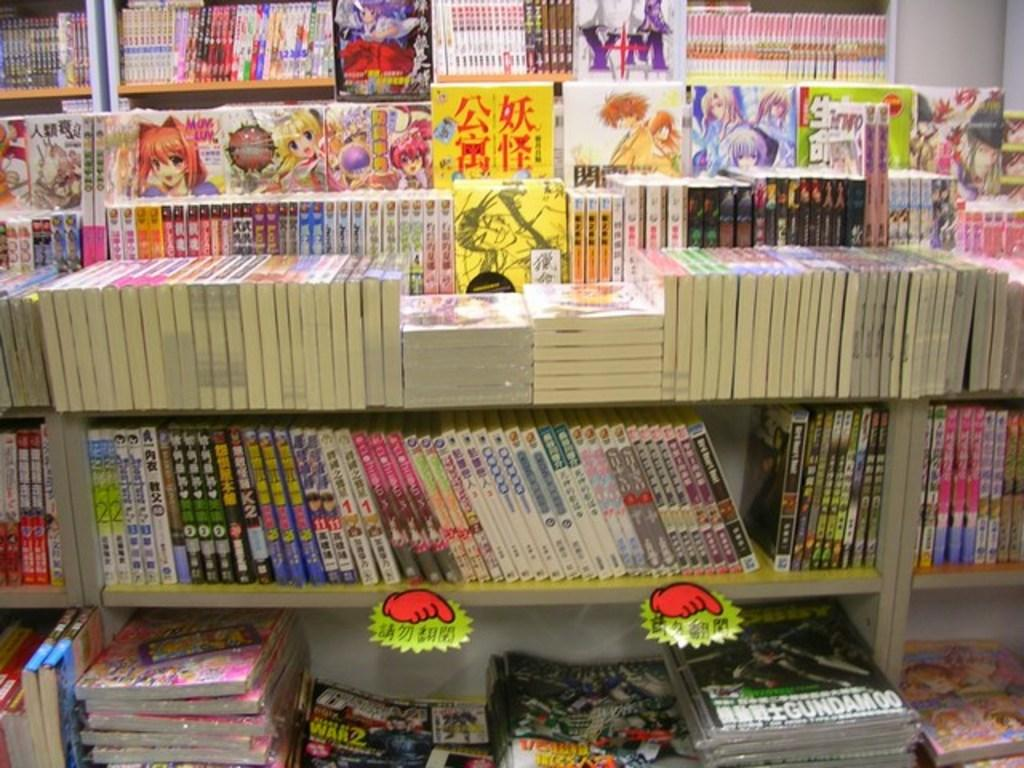<image>
Give a short and clear explanation of the subsequent image. A lot of books are arranged on a bookshelf in a foreign language. 